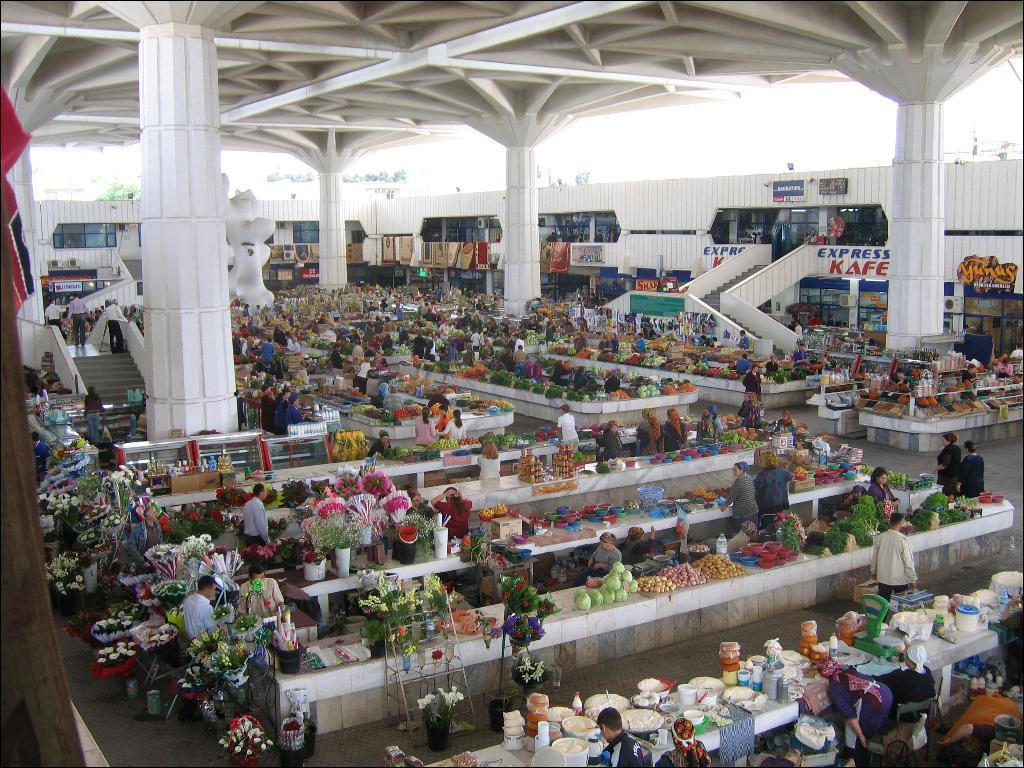<image>
Render a clear and concise summary of the photo. An indoor farmers marlet with lots of produce displayed and an express kafe next to a staircase. 